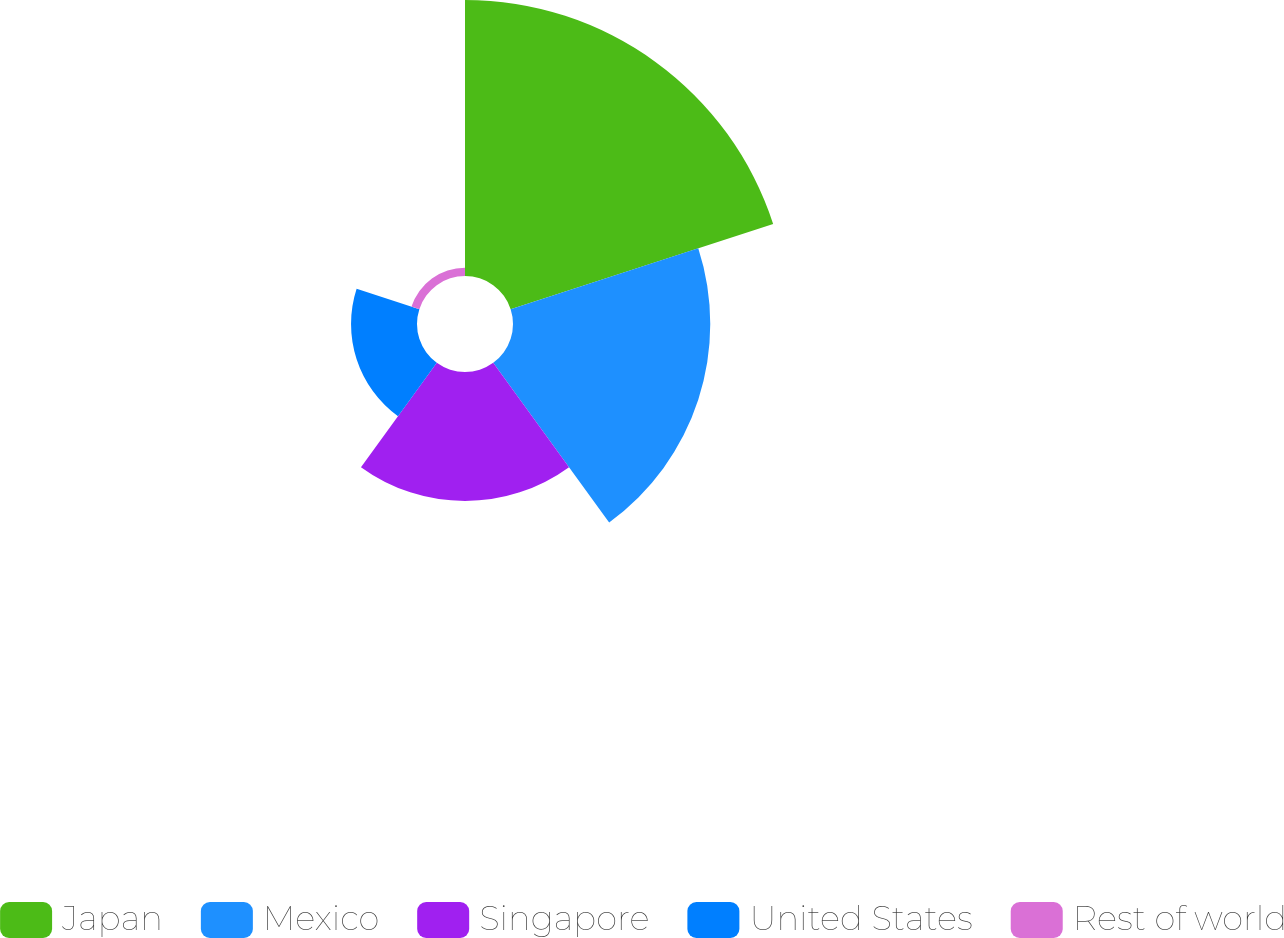Convert chart. <chart><loc_0><loc_0><loc_500><loc_500><pie_chart><fcel>Japan<fcel>Mexico<fcel>Singapore<fcel>United States<fcel>Rest of world<nl><fcel>40.8%<fcel>29.16%<fcel>19.07%<fcel>9.75%<fcel>1.22%<nl></chart> 